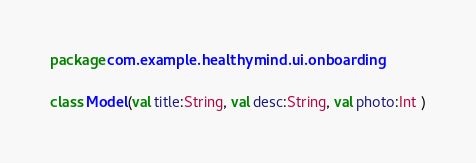<code> <loc_0><loc_0><loc_500><loc_500><_Kotlin_>package com.example.healthymind.ui.onboarding

class Model(val title:String, val desc:String, val photo:Int )</code> 